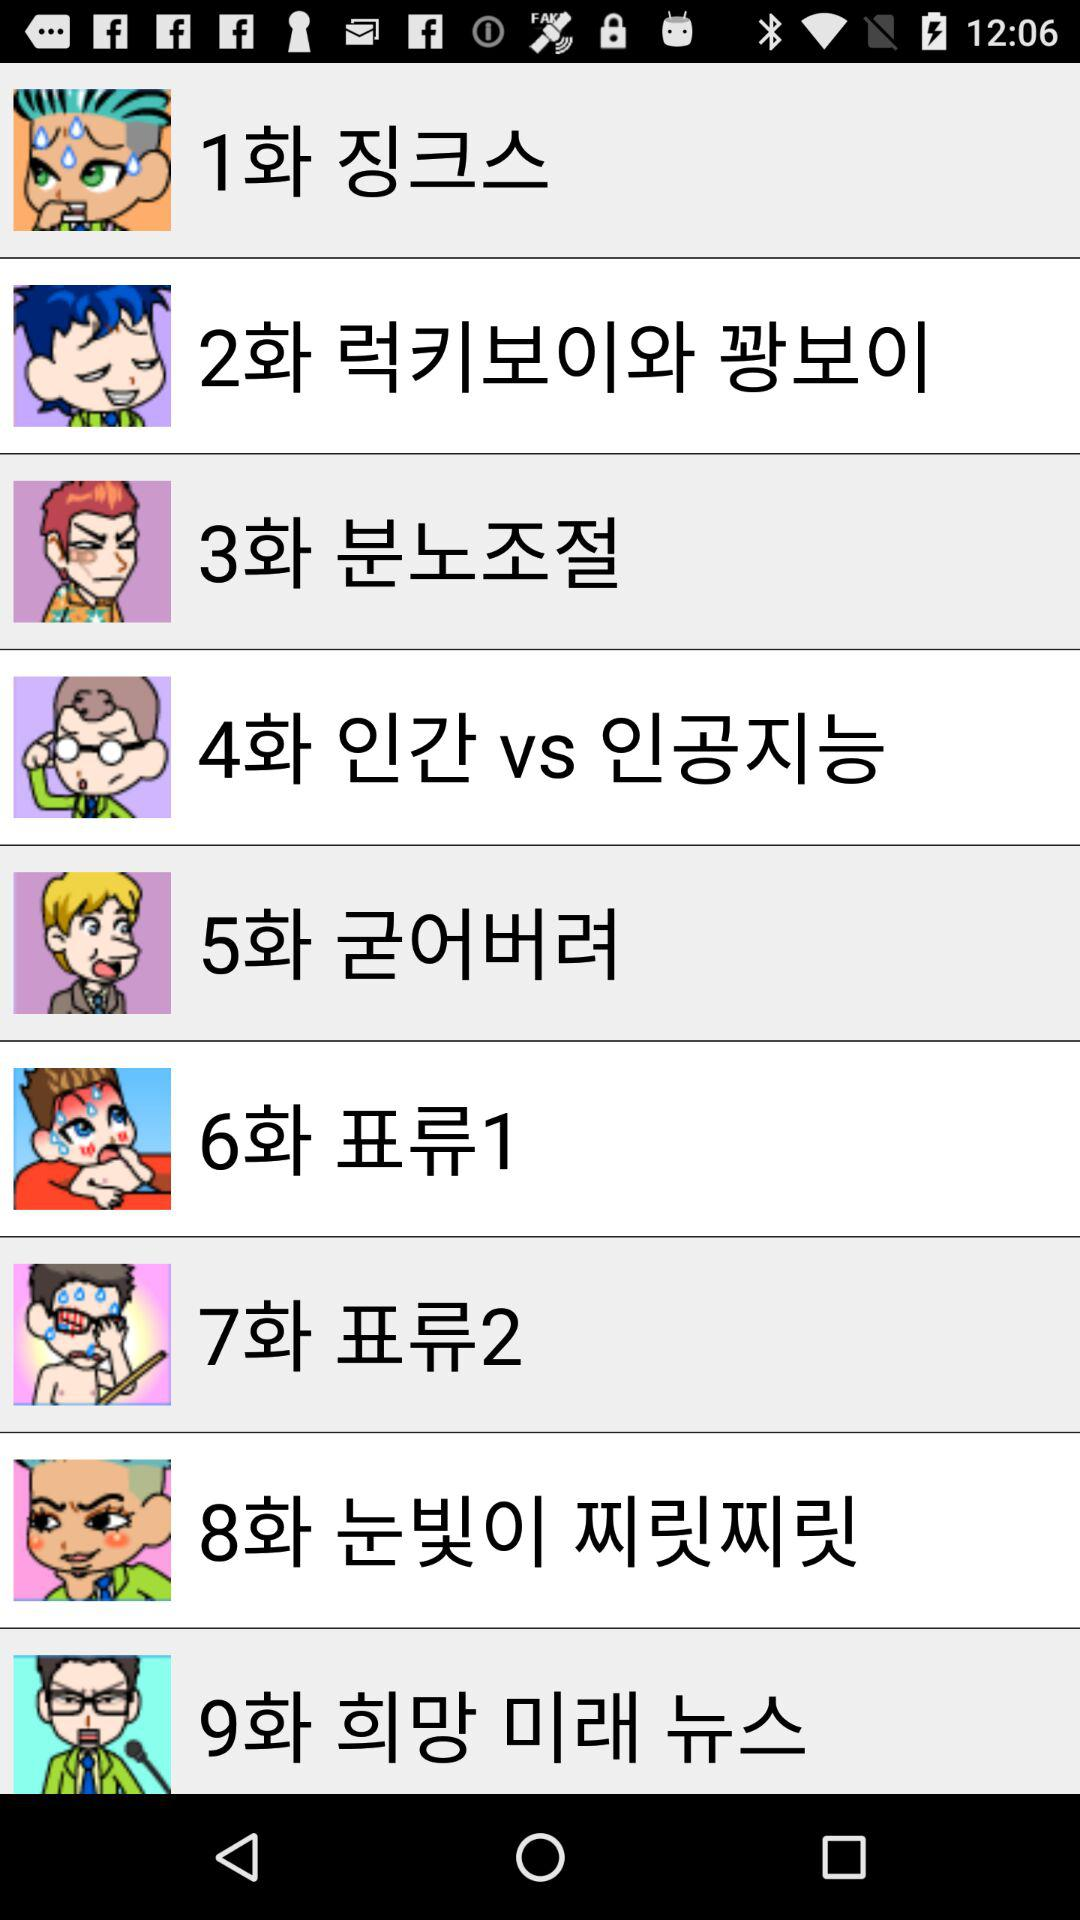How many episodes are there in this series?
Answer the question using a single word or phrase. 9 